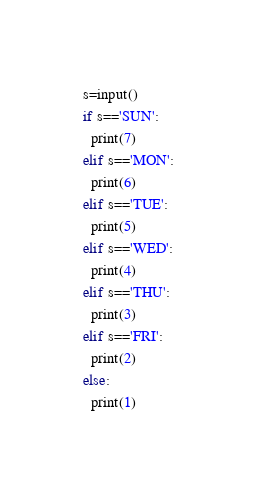Convert code to text. <code><loc_0><loc_0><loc_500><loc_500><_Python_>s=input()
if s=='SUN':
  print(7)
elif s=='MON':
  print(6)
elif s=='TUE':
  print(5)
elif s=='WED':
  print(4)
elif s=='THU':
  print(3)
elif s=='FRI':
  print(2)
else:
  print(1)</code> 